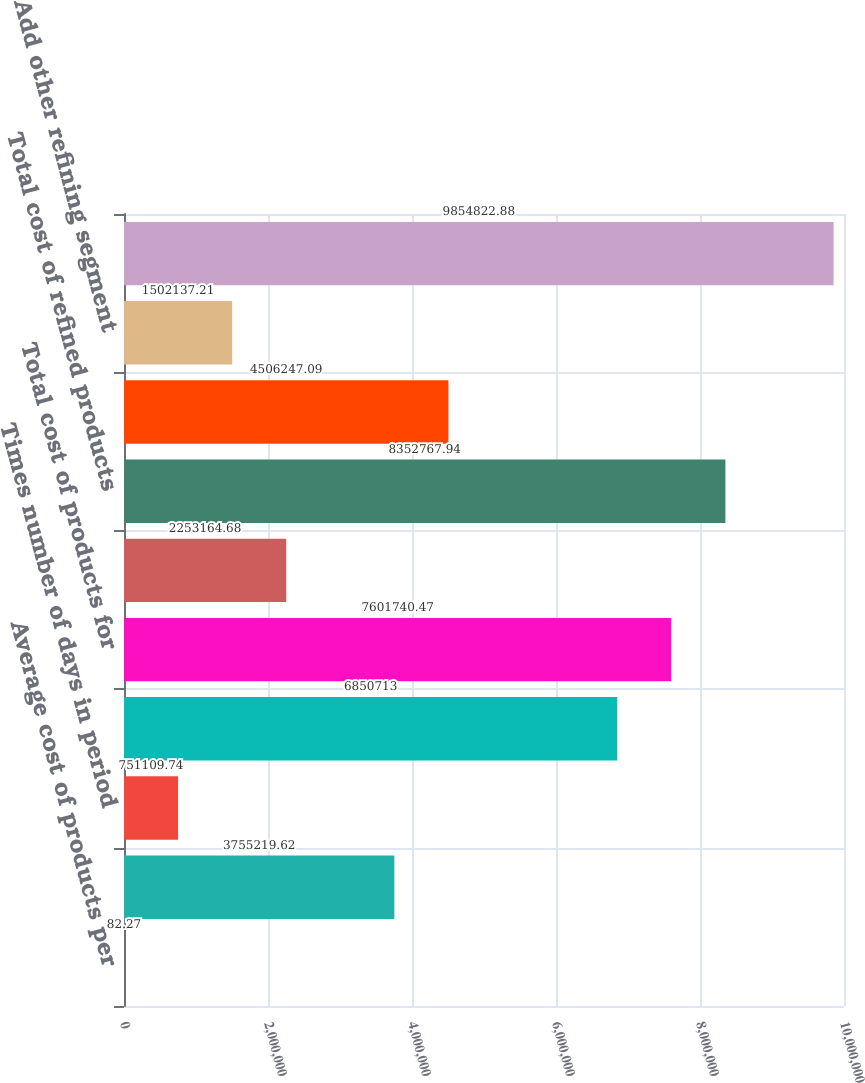Convert chart to OTSL. <chart><loc_0><loc_0><loc_500><loc_500><bar_chart><fcel>Average cost of products per<fcel>Times sales of produced<fcel>Times number of days in period<fcel>Cost of products for produced<fcel>Total cost of products for<fcel>Add refined product costs from<fcel>Total cost of refined products<fcel>Add crude oil cost of direct<fcel>Add other refining segment<fcel>Total refining segment cost of<nl><fcel>82.27<fcel>3.75522e+06<fcel>751110<fcel>6.85071e+06<fcel>7.60174e+06<fcel>2.25316e+06<fcel>8.35277e+06<fcel>4.50625e+06<fcel>1.50214e+06<fcel>9.85482e+06<nl></chart> 